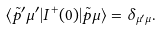<formula> <loc_0><loc_0><loc_500><loc_500>\langle { \tilde { p } } ^ { \prime } \mu ^ { \prime } | I ^ { + } ( 0 ) | { \tilde { p } } \mu \rangle = \delta _ { \mu ^ { \prime } \mu } .</formula> 